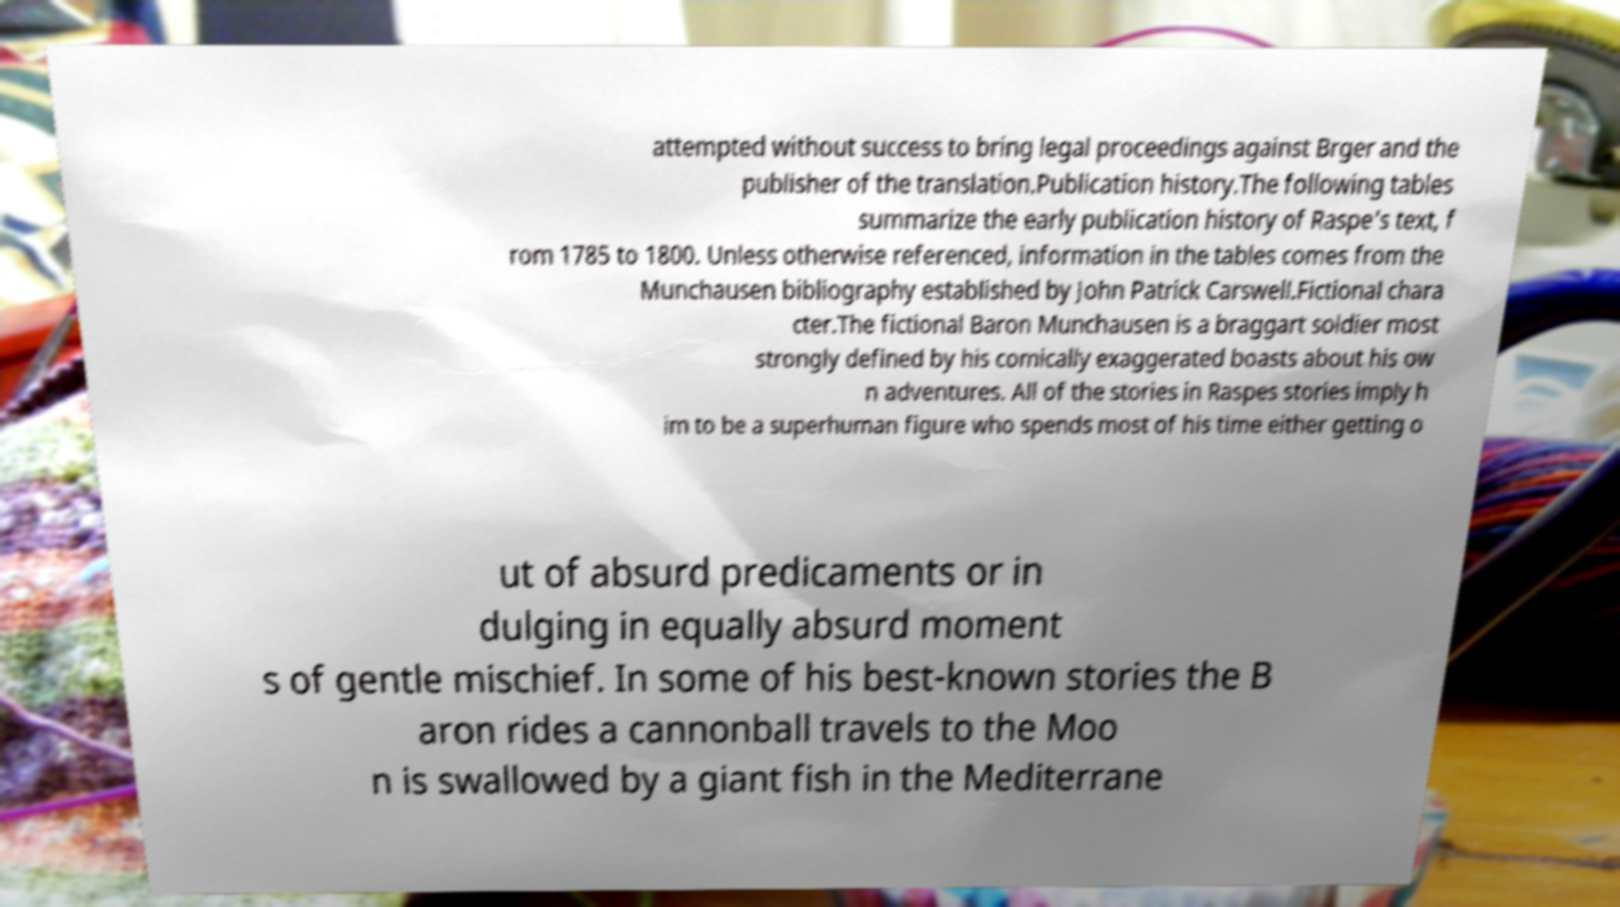Please read and relay the text visible in this image. What does it say? attempted without success to bring legal proceedings against Brger and the publisher of the translation.Publication history.The following tables summarize the early publication history of Raspe's text, f rom 1785 to 1800. Unless otherwise referenced, information in the tables comes from the Munchausen bibliography established by John Patrick Carswell.Fictional chara cter.The fictional Baron Munchausen is a braggart soldier most strongly defined by his comically exaggerated boasts about his ow n adventures. All of the stories in Raspes stories imply h im to be a superhuman figure who spends most of his time either getting o ut of absurd predicaments or in dulging in equally absurd moment s of gentle mischief. In some of his best-known stories the B aron rides a cannonball travels to the Moo n is swallowed by a giant fish in the Mediterrane 